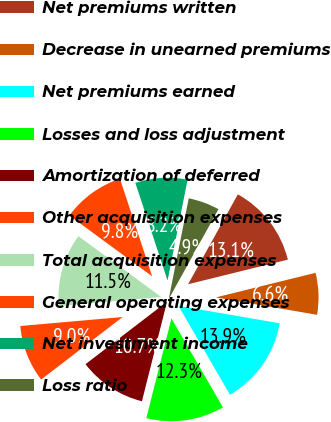<chart> <loc_0><loc_0><loc_500><loc_500><pie_chart><fcel>Net premiums written<fcel>Decrease in unearned premiums<fcel>Net premiums earned<fcel>Losses and loss adjustment<fcel>Amortization of deferred<fcel>Other acquisition expenses<fcel>Total acquisition expenses<fcel>General operating expenses<fcel>Net investment income<fcel>Loss ratio<nl><fcel>13.11%<fcel>6.56%<fcel>13.93%<fcel>12.29%<fcel>10.66%<fcel>9.02%<fcel>11.48%<fcel>9.84%<fcel>8.2%<fcel>4.92%<nl></chart> 